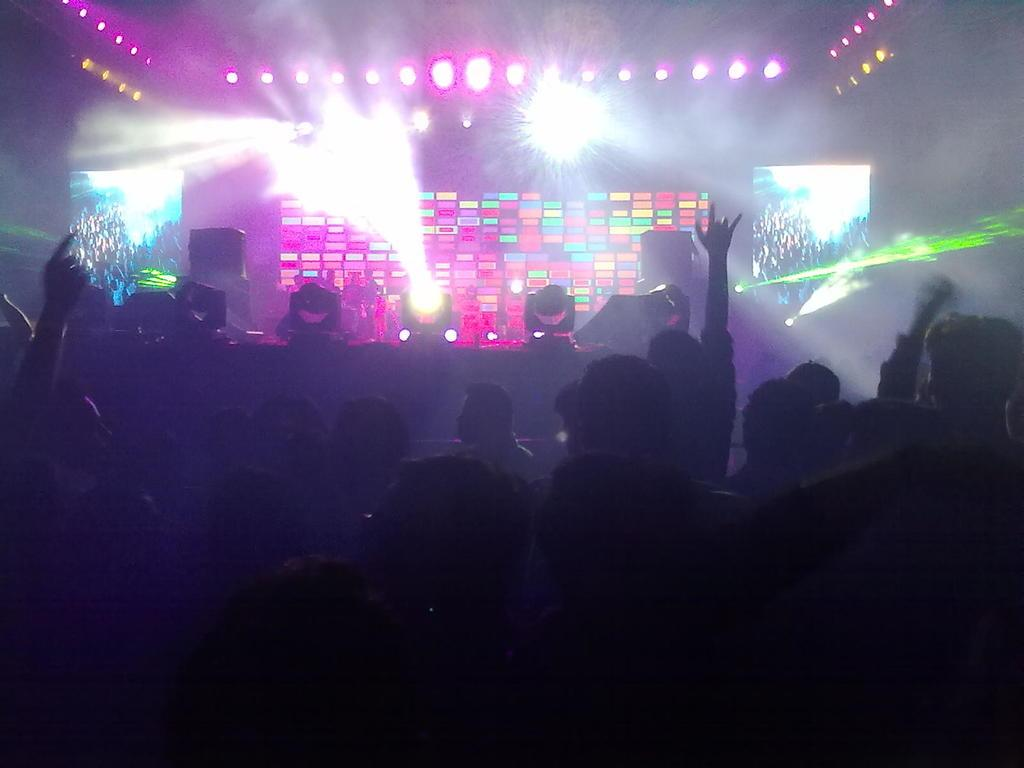What is the main object in the middle of the image? There is a disco light in the middle of the image. Can you describe the people in the image? There are people in the image, from left to right. How do the people in the image appear to be feeling? The people appear to be enjoying themselves. Can you tell me how many ducks are present in the image? There are no ducks present in the image. What type of mark can be seen on the disco light in the image? There is no mention of any mark on the disco light in the image. 